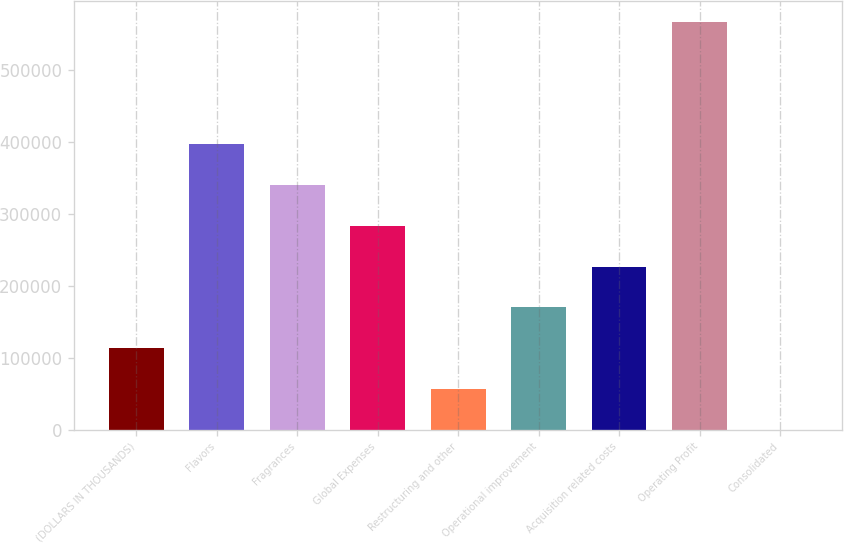<chart> <loc_0><loc_0><loc_500><loc_500><bar_chart><fcel>(DOLLARS IN THOUSANDS)<fcel>Flavors<fcel>Fragrances<fcel>Global Expenses<fcel>Restructuring and other<fcel>Operational improvement<fcel>Acquisition related costs<fcel>Operating Profit<fcel>Consolidated<nl><fcel>113486<fcel>397155<fcel>340421<fcel>283687<fcel>56752<fcel>170220<fcel>226953<fcel>567356<fcel>18.2<nl></chart> 